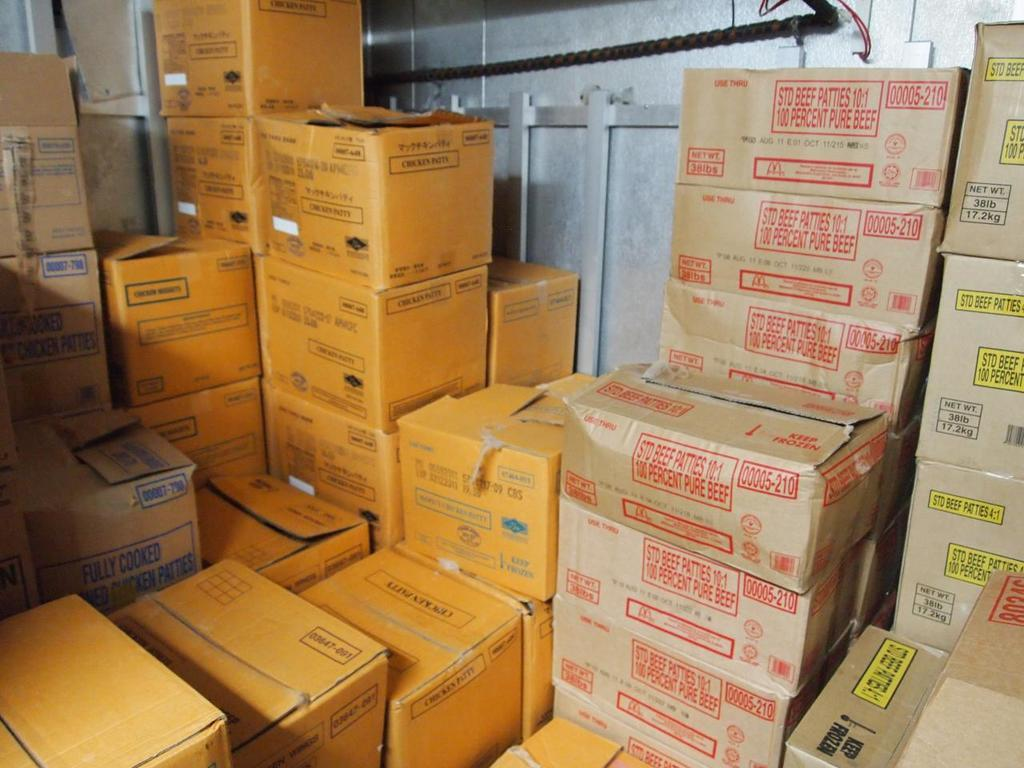<image>
Render a clear and concise summary of the photo. A bunch of boxes that says 100 percent pure beef. 